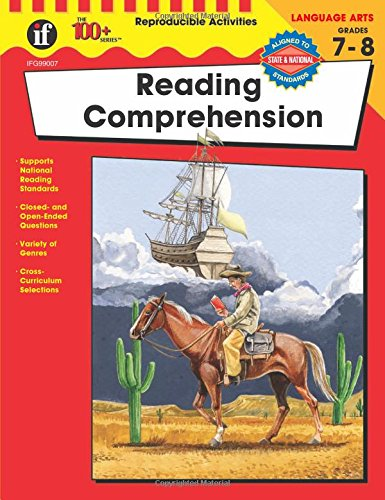What skills does this book help develop for students? The book helps develop a variety of skills including critical thinking, inferencing, vocabulary enlargement, and understanding of different text structures and genres, all vital for academic success in Language Arts. How is the content structured to facilitate learning? The content is structured into thematic units that cater to different interests, packed with closed and open-ended questions which encourage deep thinking and engagement with the text. 